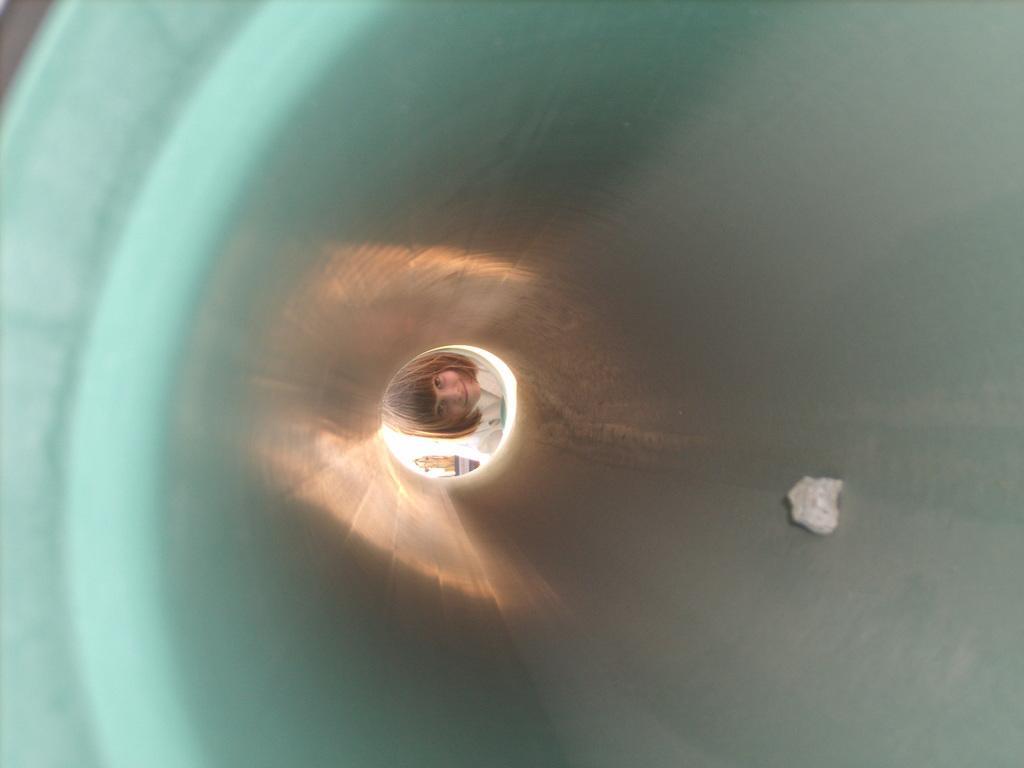Describe this image in one or two sentences. In the center of the image we can see a child. We can also see a crushed paper inside a tunnel. 